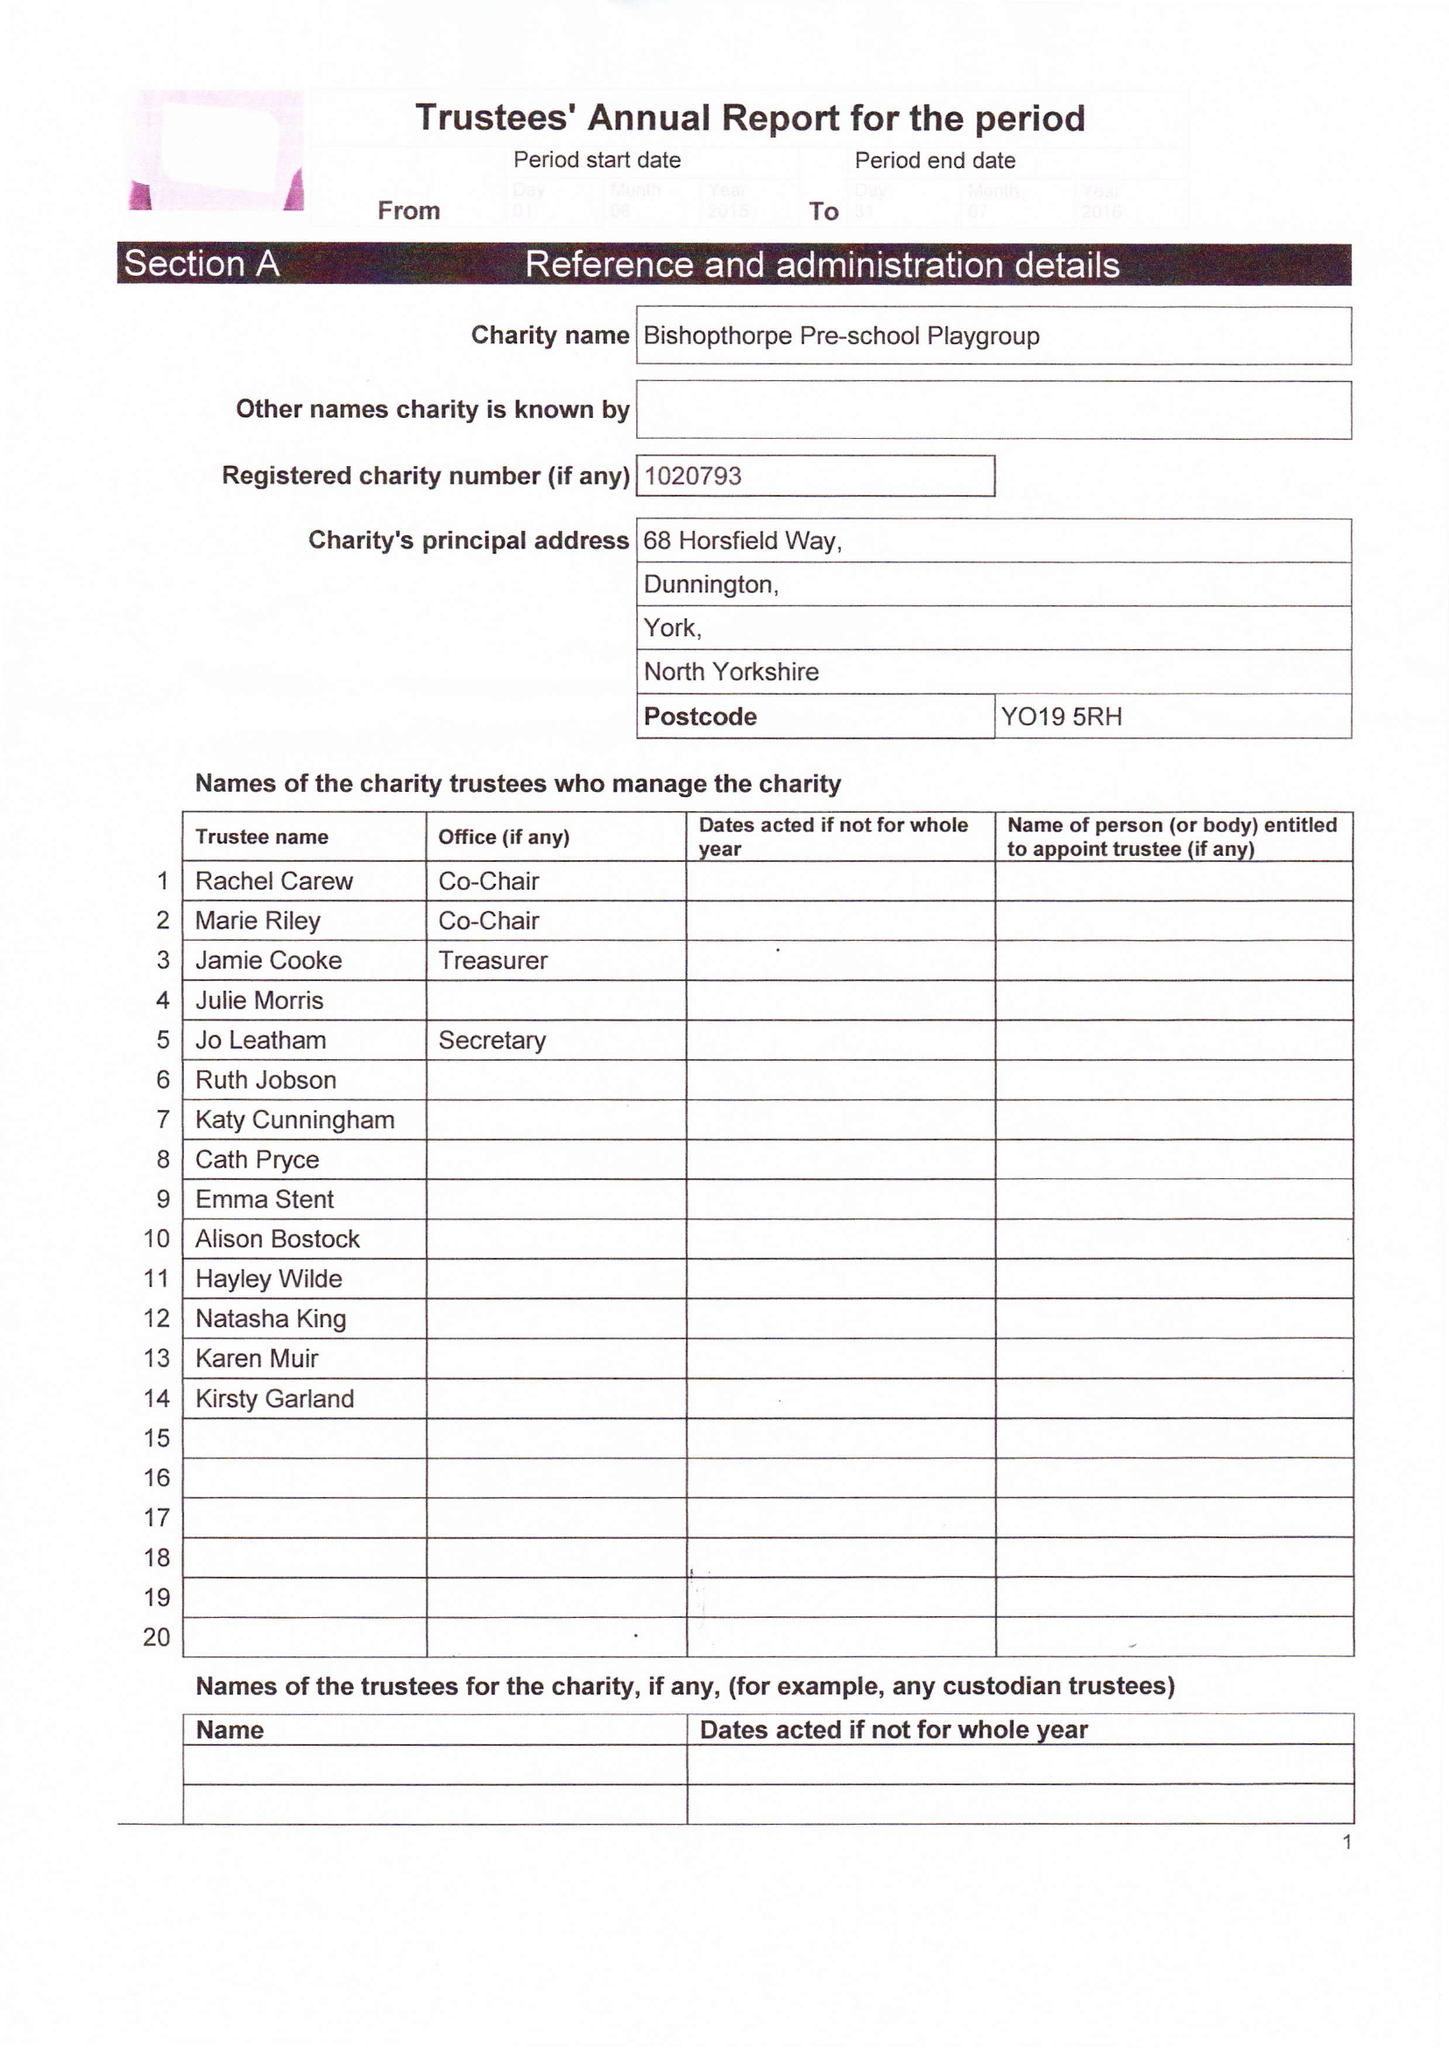What is the value for the report_date?
Answer the question using a single word or phrase. 2016-07-31 